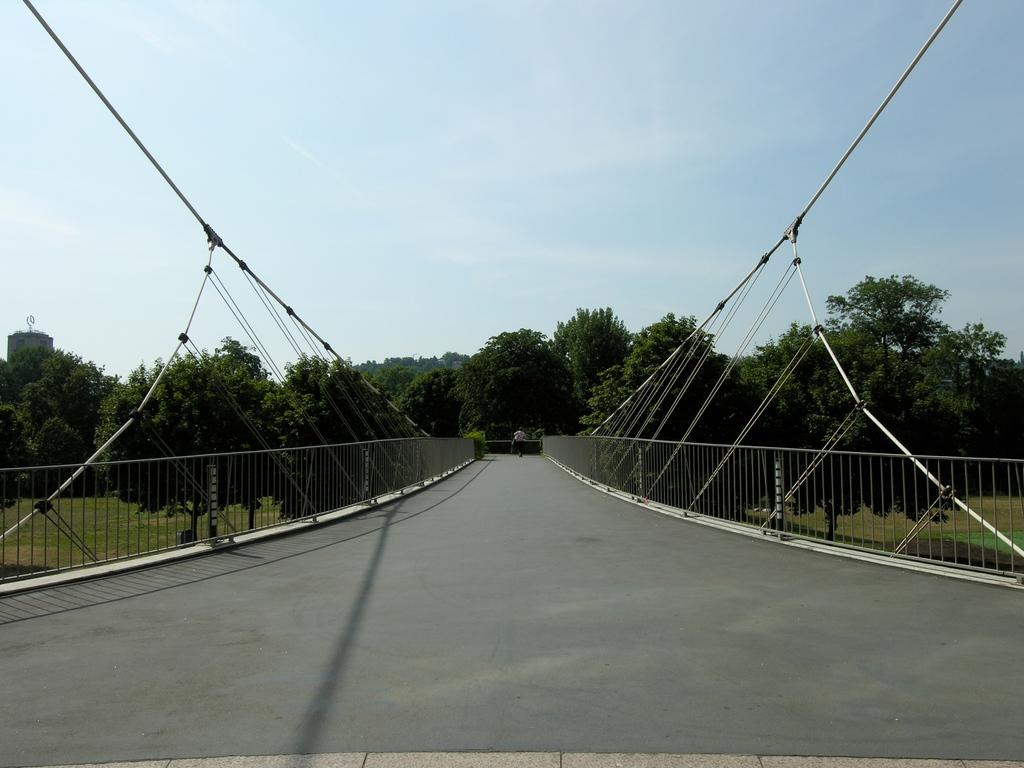What structure is located at the front of the image? There is a bridge in the front of the image. What type of vegetation and landscape can be seen in the background of the image? There are trees and grass in the background of the image. Can you describe the person in the image? There is a person in the middle of the image. What is visible at the top of the image? The sky is visible at the top of the image. How many legs can be seen on the birds in the image? There are no birds present in the image, so it is not possible to determine the number of legs on any birds. 